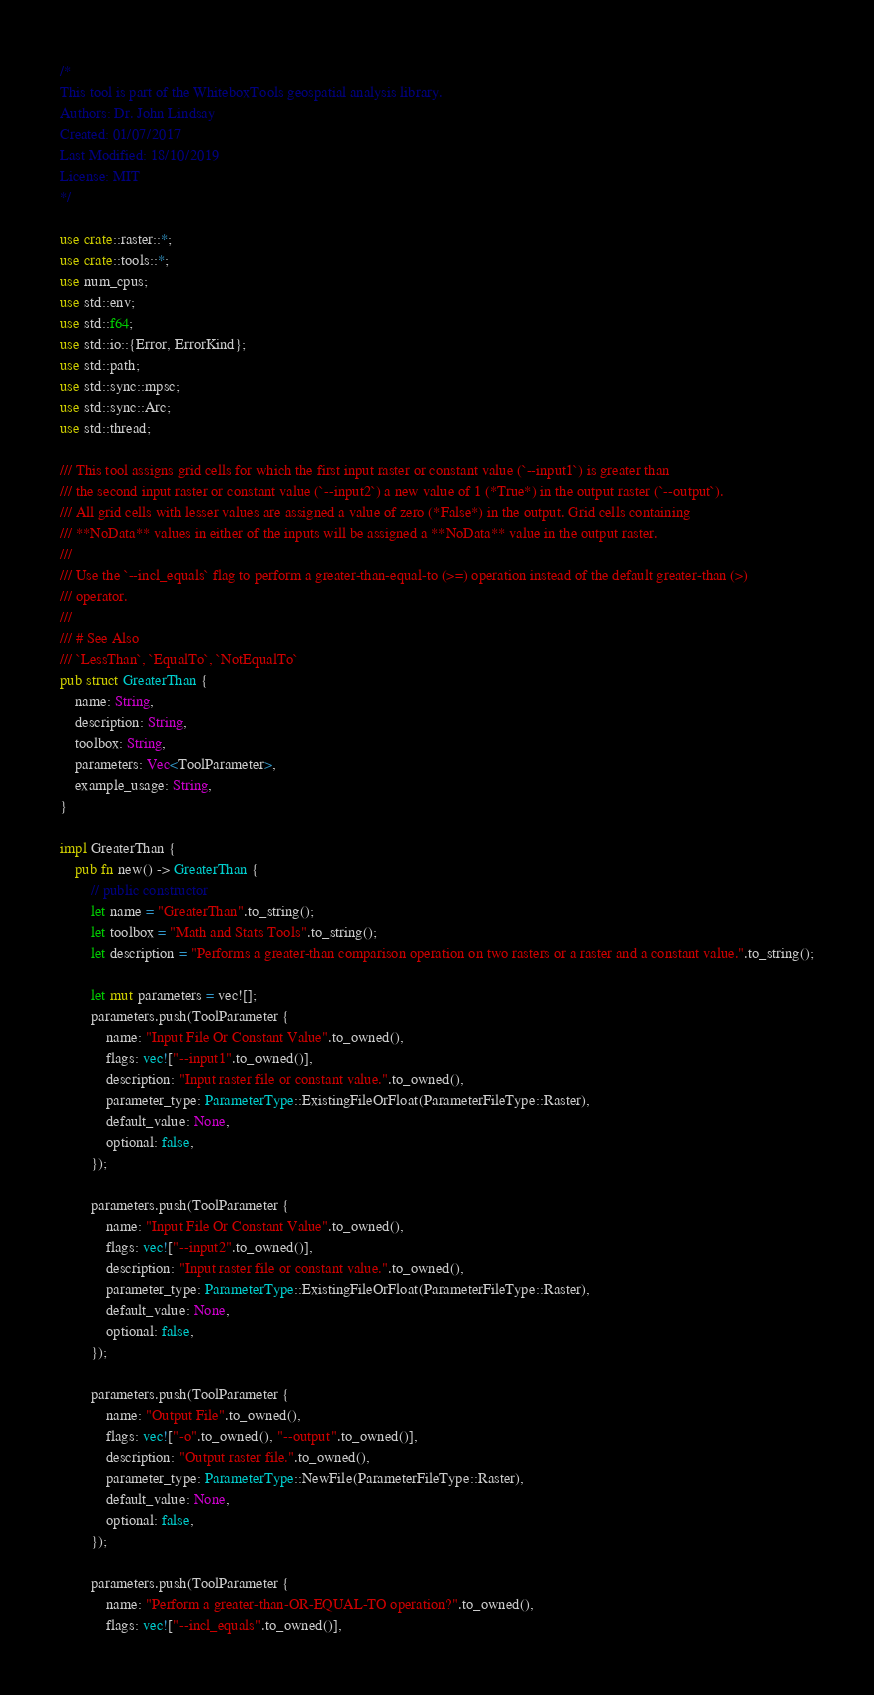<code> <loc_0><loc_0><loc_500><loc_500><_Rust_>/*
This tool is part of the WhiteboxTools geospatial analysis library.
Authors: Dr. John Lindsay
Created: 01/07/2017
Last Modified: 18/10/2019
License: MIT
*/

use crate::raster::*;
use crate::tools::*;
use num_cpus;
use std::env;
use std::f64;
use std::io::{Error, ErrorKind};
use std::path;
use std::sync::mpsc;
use std::sync::Arc;
use std::thread;

/// This tool assigns grid cells for which the first input raster or constant value (`--input1`) is greater than
/// the second input raster or constant value (`--input2`) a new value of 1 (*True*) in the output raster (`--output`). 
/// All grid cells with lesser values are assigned a value of zero (*False*) in the output. Grid cells containing 
/// **NoData** values in either of the inputs will be assigned a **NoData** value in the output raster.
/// 
/// Use the `--incl_equals` flag to perform a greater-than-equal-to (>=) operation instead of the default greater-than (>)
/// operator.
/// 
/// # See Also
/// `LessThan`, `EqualTo`, `NotEqualTo`
pub struct GreaterThan {
    name: String,
    description: String,
    toolbox: String,
    parameters: Vec<ToolParameter>,
    example_usage: String,
}

impl GreaterThan {
    pub fn new() -> GreaterThan {
        // public constructor
        let name = "GreaterThan".to_string();
        let toolbox = "Math and Stats Tools".to_string();
        let description = "Performs a greater-than comparison operation on two rasters or a raster and a constant value.".to_string();

        let mut parameters = vec![];
        parameters.push(ToolParameter {
            name: "Input File Or Constant Value".to_owned(),
            flags: vec!["--input1".to_owned()],
            description: "Input raster file or constant value.".to_owned(),
            parameter_type: ParameterType::ExistingFileOrFloat(ParameterFileType::Raster),
            default_value: None,
            optional: false,
        });

        parameters.push(ToolParameter {
            name: "Input File Or Constant Value".to_owned(),
            flags: vec!["--input2".to_owned()],
            description: "Input raster file or constant value.".to_owned(),
            parameter_type: ParameterType::ExistingFileOrFloat(ParameterFileType::Raster),
            default_value: None,
            optional: false,
        });

        parameters.push(ToolParameter {
            name: "Output File".to_owned(),
            flags: vec!["-o".to_owned(), "--output".to_owned()],
            description: "Output raster file.".to_owned(),
            parameter_type: ParameterType::NewFile(ParameterFileType::Raster),
            default_value: None,
            optional: false,
        });

        parameters.push(ToolParameter {
            name: "Perform a greater-than-OR-EQUAL-TO operation?".to_owned(),
            flags: vec!["--incl_equals".to_owned()],</code> 